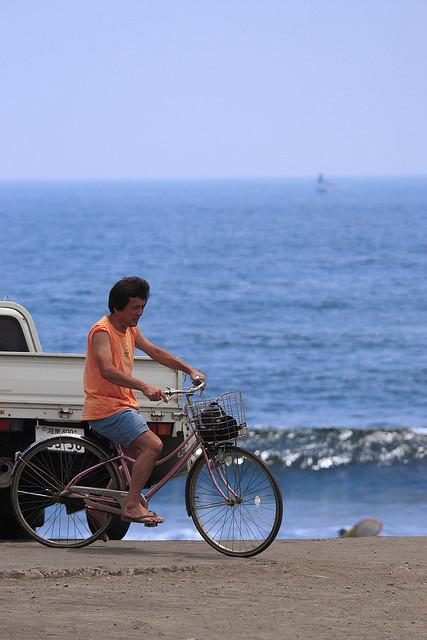What kind of power does the pink bicycle run on? man 